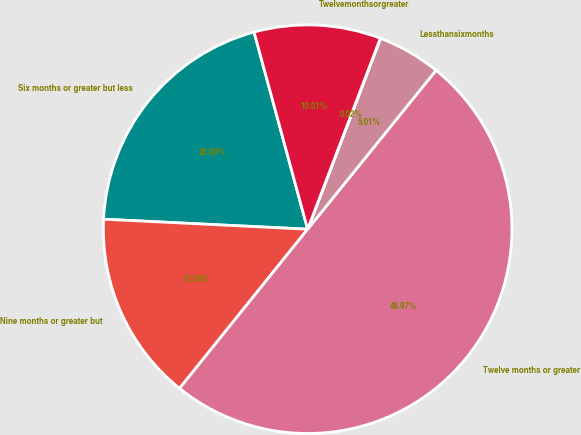Convert chart. <chart><loc_0><loc_0><loc_500><loc_500><pie_chart><fcel>Six months or greater but less<fcel>Nine months or greater but<fcel>Twelve months or greater<fcel>Lessthansixmonths<fcel>Unnamed: 4<fcel>Twelvemonthsorgreater<nl><fcel>20.0%<fcel>15.0%<fcel>49.97%<fcel>5.01%<fcel>0.02%<fcel>10.01%<nl></chart> 